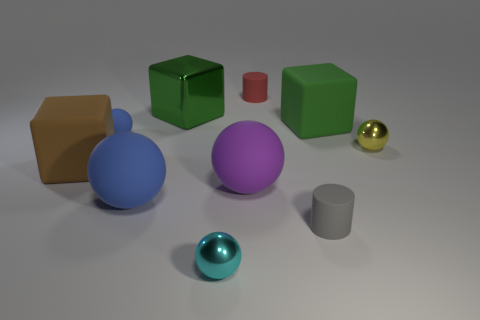There is a red matte cylinder; is its size the same as the rubber ball to the right of the green metallic object?
Make the answer very short. No. There is a rubber sphere that is on the right side of the large green metal block that is behind the tiny blue matte object; what is its size?
Provide a succinct answer. Large. How many tiny blue balls are the same material as the big brown object?
Offer a terse response. 1. Are any small green shiny balls visible?
Your response must be concise. No. What is the size of the cylinder that is behind the brown matte thing?
Provide a short and direct response. Small. How many other blocks have the same color as the shiny block?
Make the answer very short. 1. How many blocks are either brown things or metal things?
Your answer should be compact. 2. There is a small thing that is in front of the large blue rubber sphere and behind the tiny cyan sphere; what shape is it?
Give a very brief answer. Cylinder. Are there any other blocks of the same size as the green rubber cube?
Provide a succinct answer. Yes. What number of objects are either large blue rubber things that are in front of the purple rubber object or green blocks?
Provide a short and direct response. 3. 